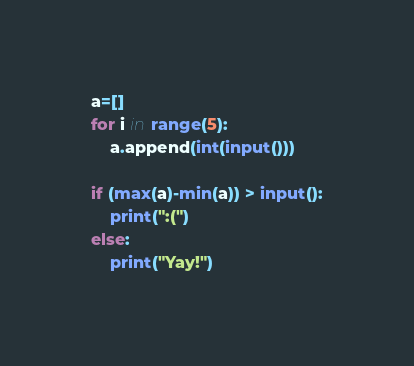Convert code to text. <code><loc_0><loc_0><loc_500><loc_500><_Python_>a=[]
for i in range(5):
    a.append(int(input()))

if (max(a)-min(a)) > input():
    print(":(")
else:
    print("Yay!")
</code> 